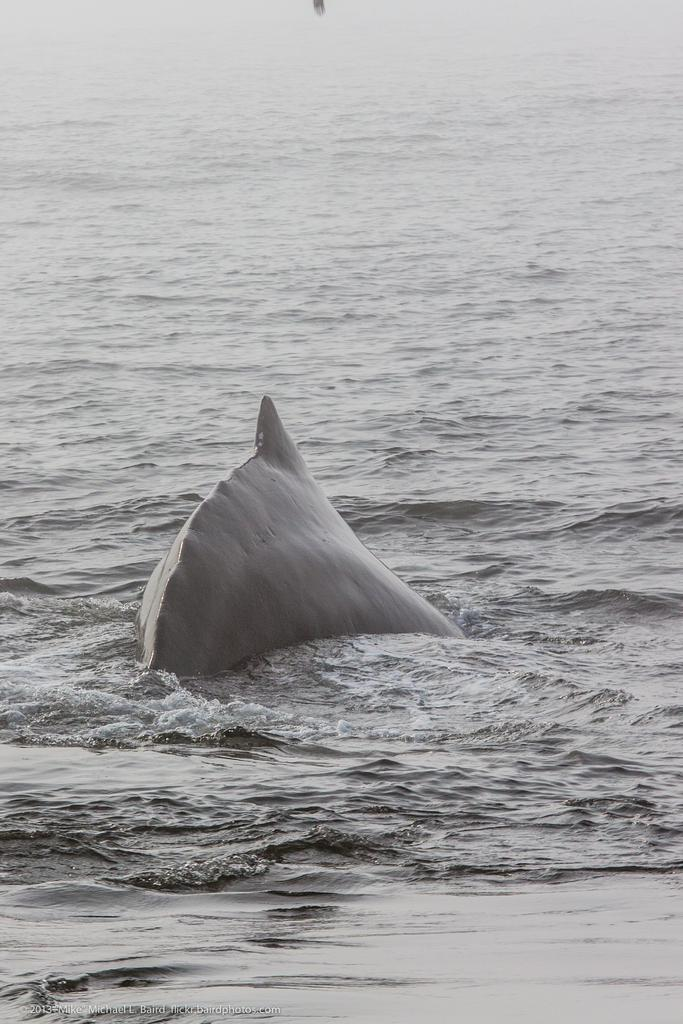What is the main subject of the image? The main subject of the image is a fish. Where is the fish located? The fish is on a water body. What type of stove is used to cook the fish in the image? There is no stove present in the image, as it features a fish on a water body. Who is the owner of the fish in the image? There is no indication of ownership in the image, as it only shows a fish on a water body. 